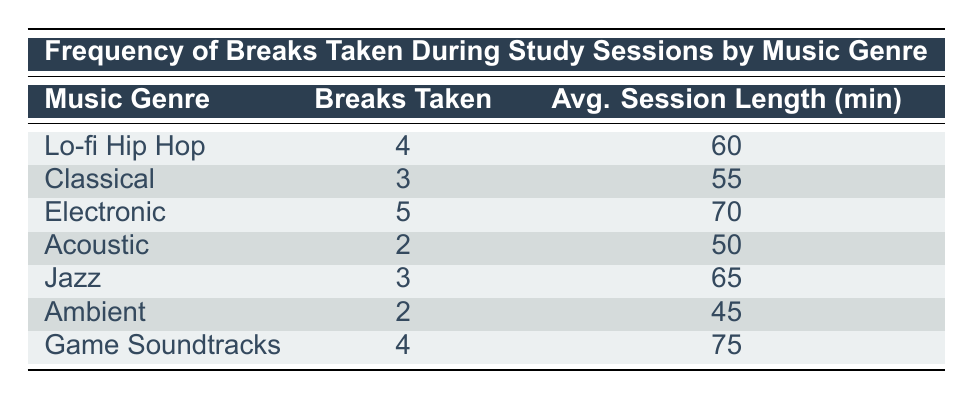What is the maximum number of breaks taken during a study session? The maximum number of breaks taken is found by looking at the "Breaks Taken" column. The values are 4, 3, 5, 2, 3, 2, and 4. The highest value among these is 5.
Answer: 5 Which music genre had the least number of breaks taken? To find the genre with the least breaks taken, we review the "Breaks Taken" column. The minimum value is 2, which corresponds to both "Acoustic" and "Ambient."
Answer: Acoustic and Ambient What is the average session length for the study sessions using "Electronic" music? By looking into the "Avg. Session Length (min)" for "Electronic," the value shown is 70.
Answer: 70 Is it true that "Classical" music had more breaks taken than "Ambient" music? We need to compare the "Breaks Taken" for "Classical" (3) and "Ambient" (2). Since 3 is greater than 2, the statement is true.
Answer: Yes What is the total number of breaks taken across all music genres? To find the total, we sum the "Breaks Taken" for each genre: 4 + 3 + 5 + 2 + 3 + 2 + 4 = 23.
Answer: 23 What music genre(s) took breaks equal to or fewer than 3? We filter the "Breaks Taken" column for values less than or equal to 3, finding "Classical" (3), "Acoustic" (2), "Jazz" (3), and "Ambient" (2).
Answer: Classical, Acoustic, Jazz, Ambient Which music genre had the highest average session length? Examine the "Avg. Session Length (min)" column. The values are 60, 55, 70, 50, 65, 45, and 75. The highest value is 75, corresponding to "Game Soundtracks."
Answer: Game Soundtracks On average, how many breaks were taken per session for "Lo-fi Hip Hop" and "Jazz"? The breaks for "Lo-fi Hip Hop" is 4 and for "Jazz" is 3. To find the average, we sum them (4 + 3 = 7) and divide by 2, resulting in 7/2 = 3.5.
Answer: 3.5 How many music genres had exactly 3 breaks taken? We can check the "Breaks Taken" column for occurrences of the value 3. The genres with 3 breaks are "Classical" and "Jazz," totaling 2 genres.
Answer: 2 